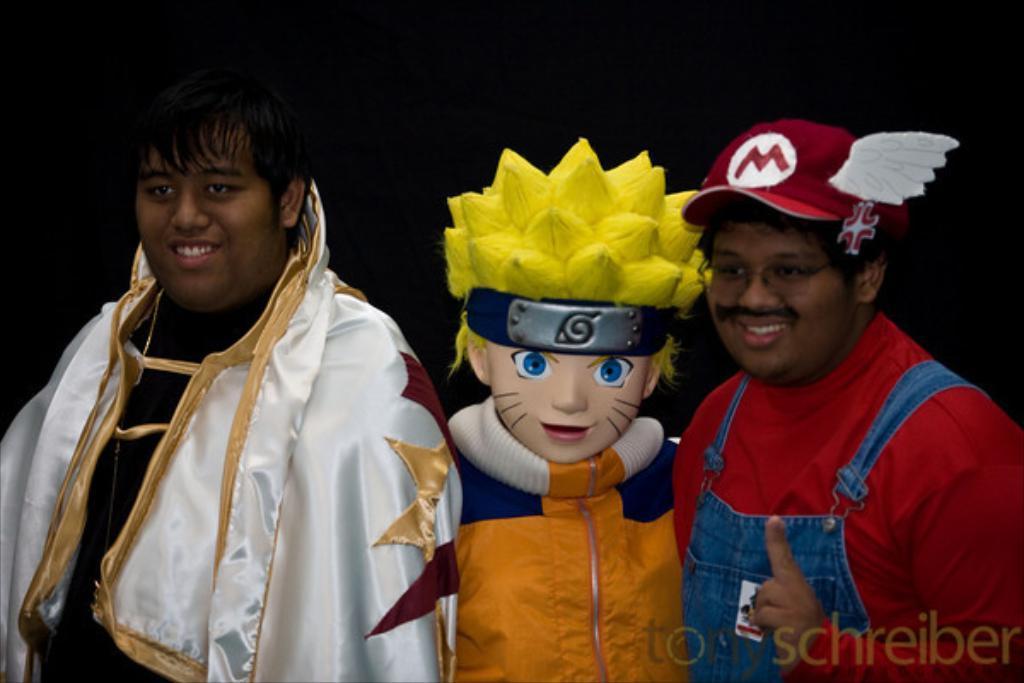Can you describe this image briefly? In this image I can see on the left side a boy is smiling, he wore shining white color cloth. In the middle there is a doll in the shape of a boy. On the right side a boy wore red color t-shirt, cap. 